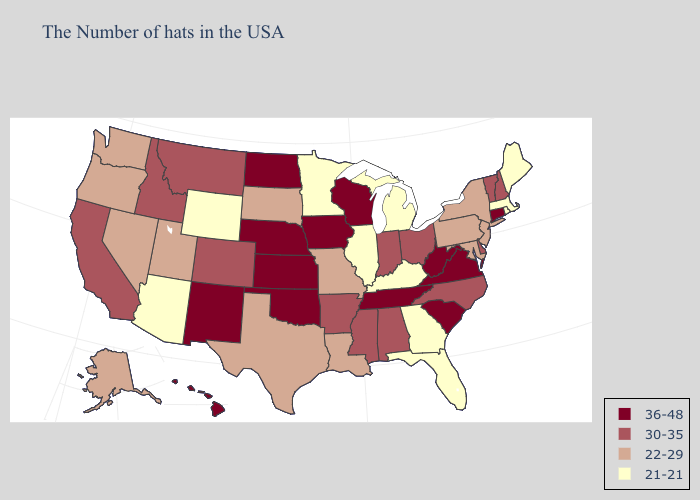Does New Jersey have the same value as Texas?
Quick response, please. Yes. Does Arkansas have the lowest value in the South?
Give a very brief answer. No. What is the highest value in states that border Minnesota?
Answer briefly. 36-48. Does Idaho have the highest value in the USA?
Give a very brief answer. No. What is the lowest value in states that border Michigan?
Keep it brief. 30-35. Name the states that have a value in the range 36-48?
Short answer required. Connecticut, Virginia, South Carolina, West Virginia, Tennessee, Wisconsin, Iowa, Kansas, Nebraska, Oklahoma, North Dakota, New Mexico, Hawaii. Which states have the lowest value in the USA?
Be succinct. Maine, Massachusetts, Rhode Island, Florida, Georgia, Michigan, Kentucky, Illinois, Minnesota, Wyoming, Arizona. What is the highest value in the MidWest ?
Be succinct. 36-48. Name the states that have a value in the range 21-21?
Write a very short answer. Maine, Massachusetts, Rhode Island, Florida, Georgia, Michigan, Kentucky, Illinois, Minnesota, Wyoming, Arizona. Is the legend a continuous bar?
Quick response, please. No. Which states have the highest value in the USA?
Quick response, please. Connecticut, Virginia, South Carolina, West Virginia, Tennessee, Wisconsin, Iowa, Kansas, Nebraska, Oklahoma, North Dakota, New Mexico, Hawaii. Does Idaho have the lowest value in the USA?
Concise answer only. No. Does Wisconsin have the highest value in the USA?
Short answer required. Yes. Which states have the highest value in the USA?
Keep it brief. Connecticut, Virginia, South Carolina, West Virginia, Tennessee, Wisconsin, Iowa, Kansas, Nebraska, Oklahoma, North Dakota, New Mexico, Hawaii. What is the highest value in the USA?
Quick response, please. 36-48. 